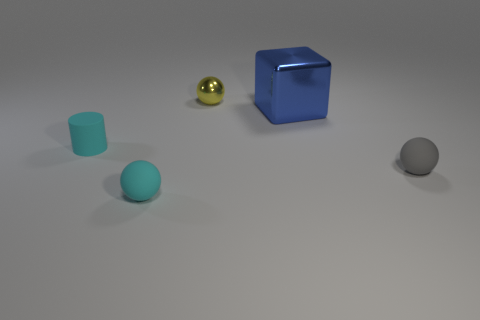Is there anything else that is the same size as the blue thing?
Provide a short and direct response. No. There is a rubber object that is to the right of the small yellow metal ball; what is its shape?
Your response must be concise. Sphere. How many yellow metal objects have the same shape as the small gray matte object?
Your response must be concise. 1. There is a matte ball to the left of the large cube; does it have the same color as the rubber cylinder on the left side of the big blue thing?
Keep it short and to the point. Yes. What number of objects are gray blocks or small shiny balls?
Offer a terse response. 1. How many cyan cylinders are made of the same material as the gray ball?
Your answer should be compact. 1. Is the number of cyan spheres less than the number of red matte balls?
Your answer should be very brief. No. Do the small object on the right side of the yellow ball and the large cube have the same material?
Provide a succinct answer. No. How many balls are tiny rubber things or small shiny objects?
Your response must be concise. 3. The object that is both in front of the rubber cylinder and to the left of the blue shiny block has what shape?
Make the answer very short. Sphere. 